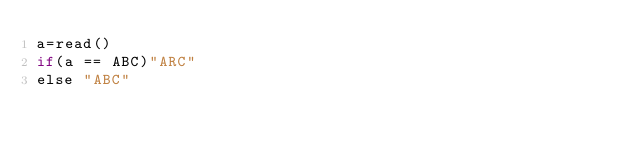<code> <loc_0><loc_0><loc_500><loc_500><_bc_>a=read()
if(a == ABC)"ARC"
else "ABC"
</code> 